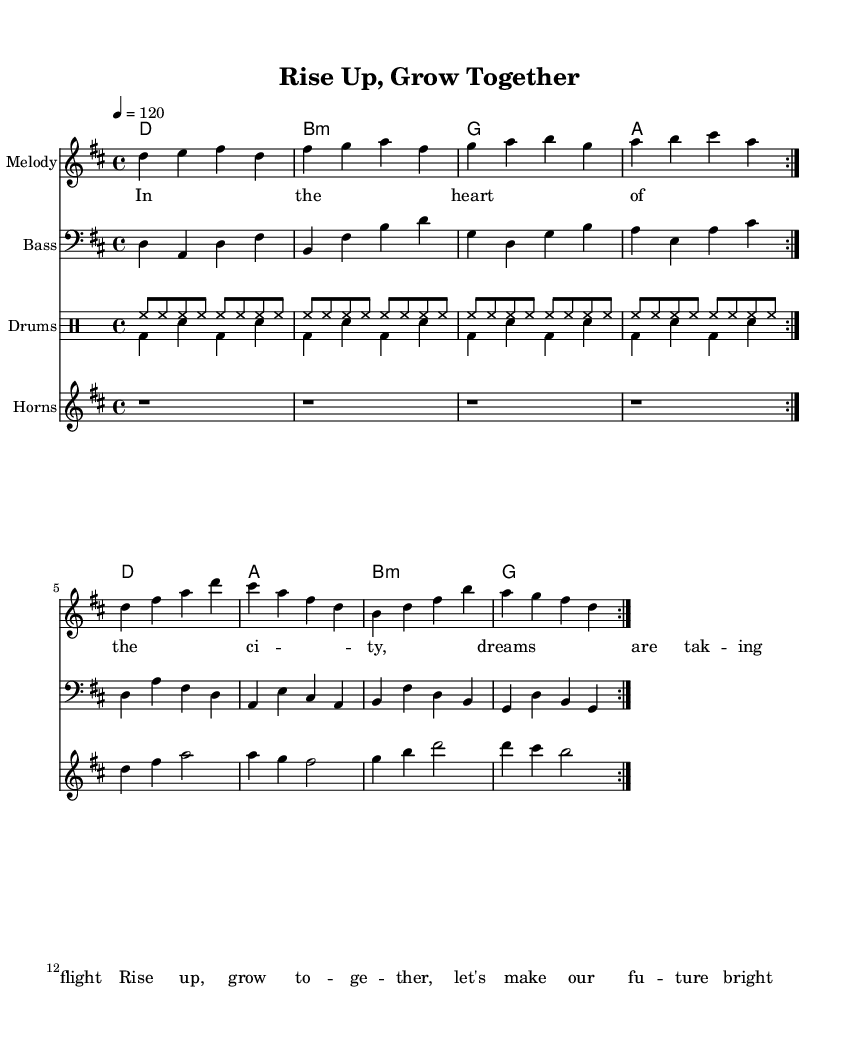What is the key signature of this music? The key signature is D major, which has two sharps: F sharp and C sharp.
Answer: D major What is the time signature of the piece? The time signature is found near the beginning of the music; in this case, it is 4/4, which means there are four beats in each measure.
Answer: 4/4 What is the tempo marking for this composition? The tempo marking is indicated by the number followed by " = " right after the time signature; here, it indicates a tempo of 120 beats per minute.
Answer: 120 How many volta repeats are there in the melody section? The melody section includes a repeat sign with the text 'volta', meaning it is designed to repeat a total of two times, as indicated by the notation.
Answer: 2 Which instruments are featured in this score? The instruments are indicated by the names associated with their respective staves; in this score, they include Melody, Bass, Drums, and Horns.
Answer: Melody, Bass, Drums, Horns What style of music does this piece represent? The overall style can be inferred from the title and the blend of rhythms and harmonies, and it showcases an upbeat soul-funk fusion.
Answer: Soul-funk fusion What is the primary thematic message of the lyrics? By analyzing the lyrics provided, the message focuses on community empowerment and entrepreneurship, encouraging collaboration for future growth.
Answer: Community empowerment 